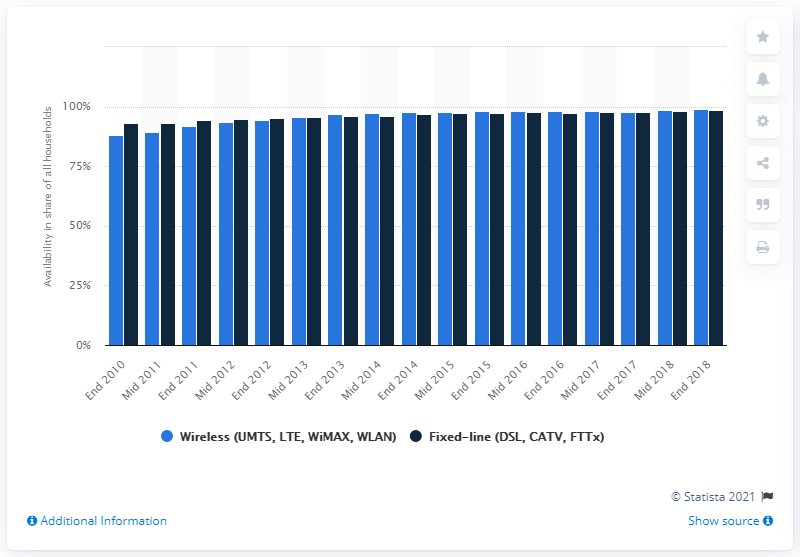Point out several critical features in this image. In 2018, 98.9% of German households had fixed-line broadband, indicating widespread access to high-speed internet. 